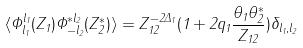Convert formula to latex. <formula><loc_0><loc_0><loc_500><loc_500>\langle \Phi ^ { l _ { 1 } } _ { l _ { 1 } } ( Z _ { 1 } ) \Phi ^ { * l _ { 2 } } _ { - l _ { 2 } } ( Z ^ { * } _ { 2 } ) \rangle = Z _ { 1 2 } ^ { - 2 \Delta _ { 1 } } ( 1 + 2 q _ { 1 } \frac { \theta _ { 1 } \theta ^ { * } _ { 2 } } { Z _ { 1 2 } } ) \delta _ { l _ { 1 } , l _ { 2 } }</formula> 